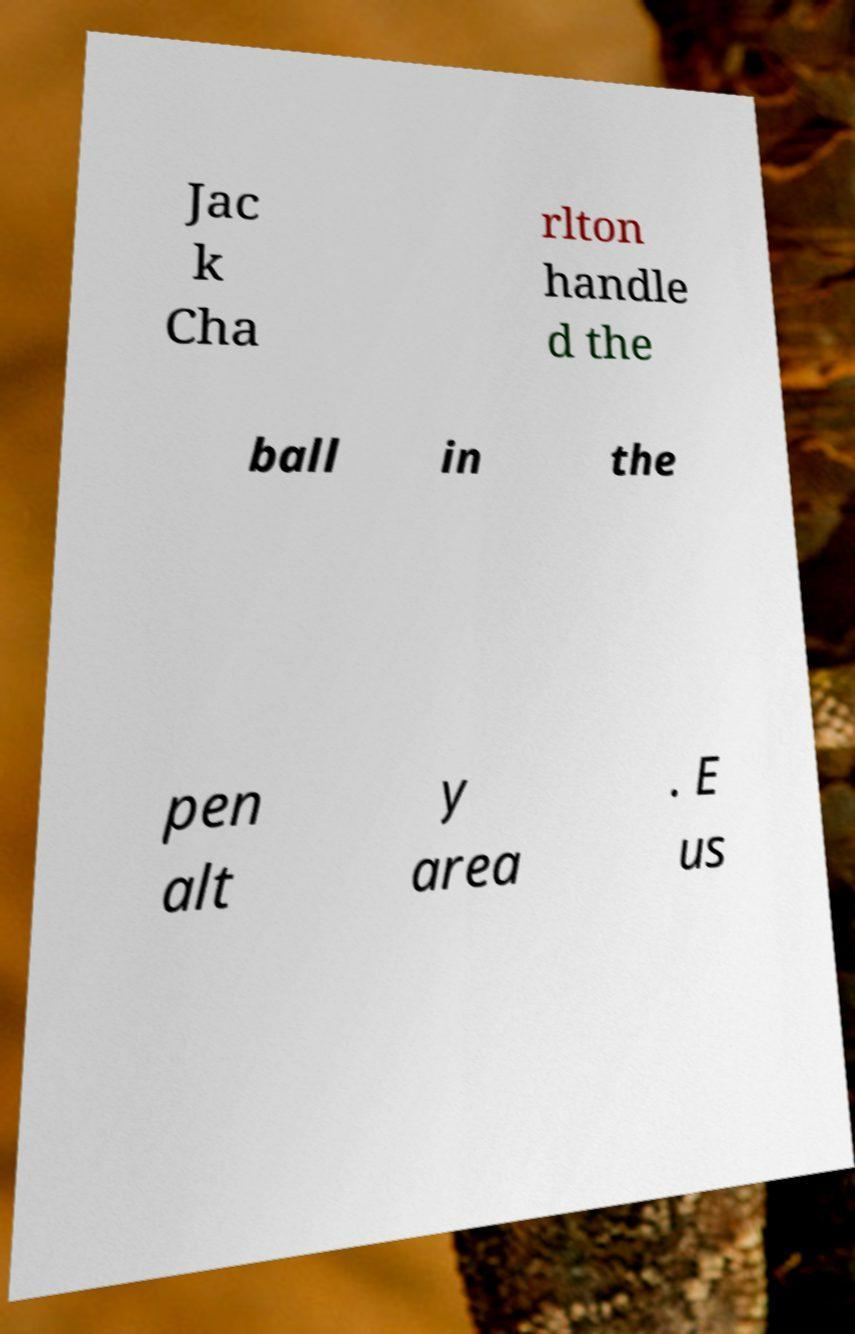There's text embedded in this image that I need extracted. Can you transcribe it verbatim? Jac k Cha rlton handle d the ball in the pen alt y area . E us 